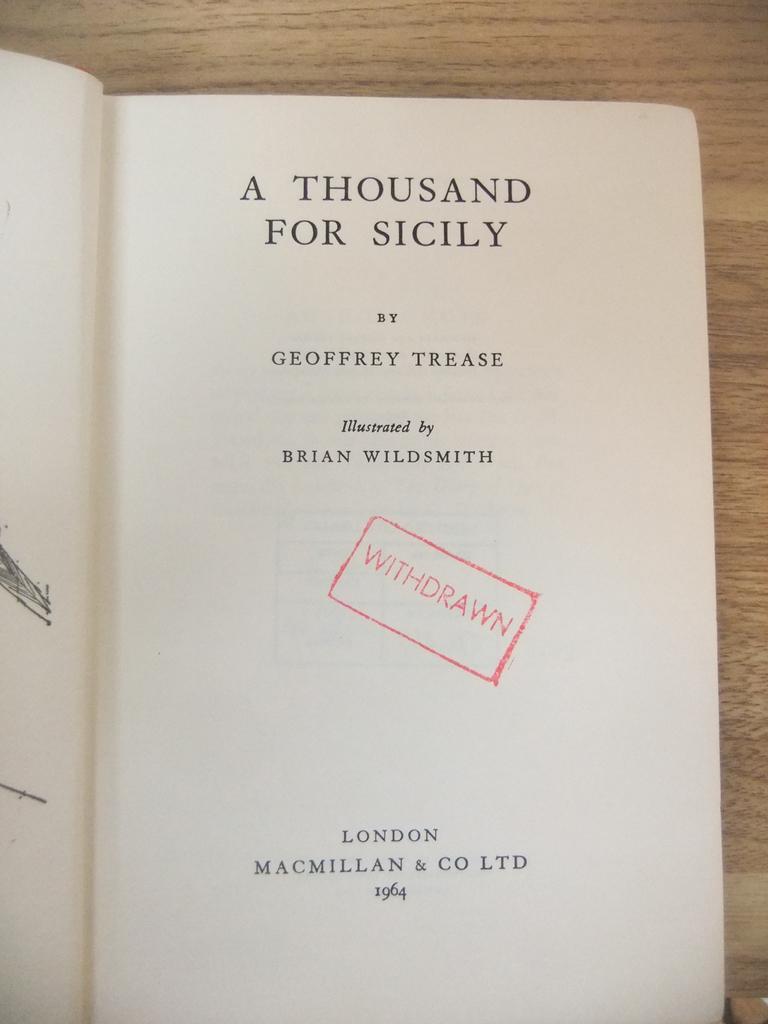Could you give a brief overview of what you see in this image? In this image we can see a book opened which is placed on a wooden surface. In the book we can see some text. 